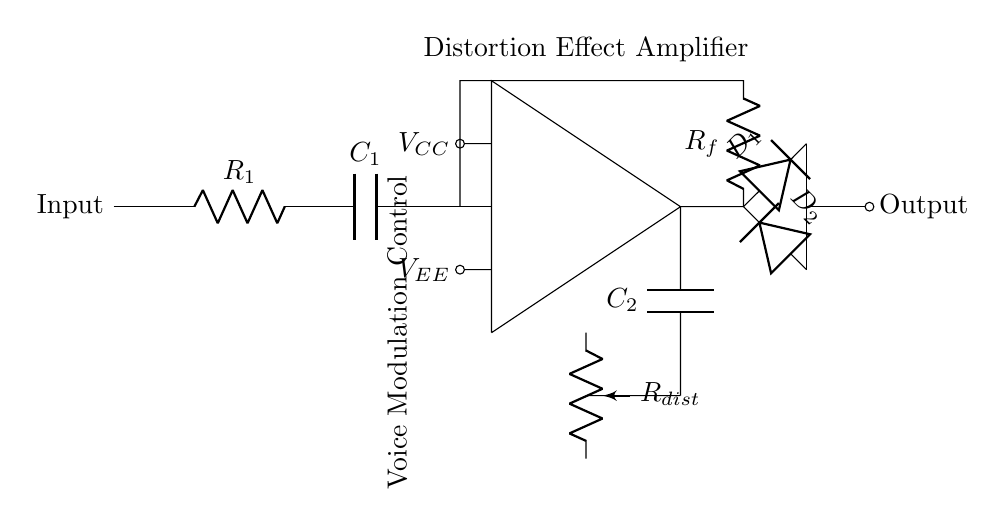What is the main component used for amplification? The main component for amplification in this circuit is the operational amplifier, denoted by the specific block shape in the diagram.
Answer: operational amplifier Which component controls distortion? The potentiometer labeled as R_dist is responsible for controlling the distortion effect in the circuit, as it can vary the resistance and thus change the amplification characteristics.
Answer: R_dist How many resistors are present in the circuit? The circuit contains two resistors: R_1 and R_f. They are crucial for the feedback and input stages of the amplifier.
Answer: 2 What do the diodes in the circuit do? The diodes D_1 and D_2 are used for clipping the output waveform, which introduces distortion by limiting the output voltage. This is beneficial for creating specific voice modulation effects.
Answer: clipping What is the purpose of the capacitor labeled C_2? The capacitor C_2 is used in the feedback loop to couple the output signal and help shape the frequency response of the amplifier's distortion characteristics.
Answer: coupling What type of circuit is this? This is a distortion effect amplifier circuit designed to create unique voice modulations, which is typically used in audio processing applications, especially in contexts like comedy sketches.
Answer: distortion effect amplifier How is the output taken from the circuit? The output is taken from the junction after the diodes and before the output node, which reflects the modified signal that has undergone amplification and distortion effects.
Answer: from the diode junction 